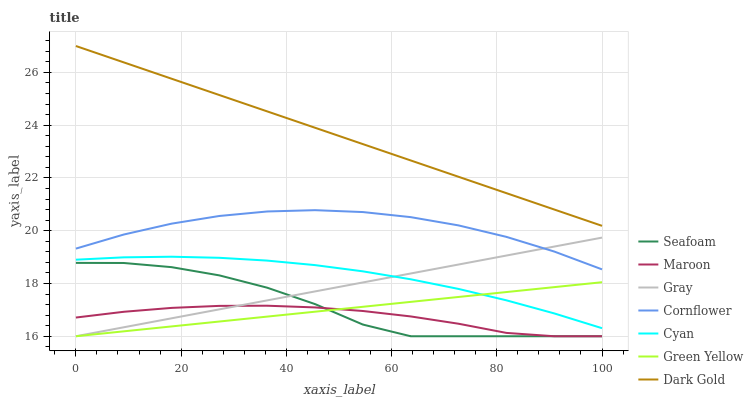Does Maroon have the minimum area under the curve?
Answer yes or no. Yes. Does Dark Gold have the maximum area under the curve?
Answer yes or no. Yes. Does Cornflower have the minimum area under the curve?
Answer yes or no. No. Does Cornflower have the maximum area under the curve?
Answer yes or no. No. Is Green Yellow the smoothest?
Answer yes or no. Yes. Is Seafoam the roughest?
Answer yes or no. Yes. Is Cornflower the smoothest?
Answer yes or no. No. Is Cornflower the roughest?
Answer yes or no. No. Does Gray have the lowest value?
Answer yes or no. Yes. Does Cornflower have the lowest value?
Answer yes or no. No. Does Dark Gold have the highest value?
Answer yes or no. Yes. Does Cornflower have the highest value?
Answer yes or no. No. Is Seafoam less than Cyan?
Answer yes or no. Yes. Is Dark Gold greater than Gray?
Answer yes or no. Yes. Does Green Yellow intersect Gray?
Answer yes or no. Yes. Is Green Yellow less than Gray?
Answer yes or no. No. Is Green Yellow greater than Gray?
Answer yes or no. No. Does Seafoam intersect Cyan?
Answer yes or no. No. 